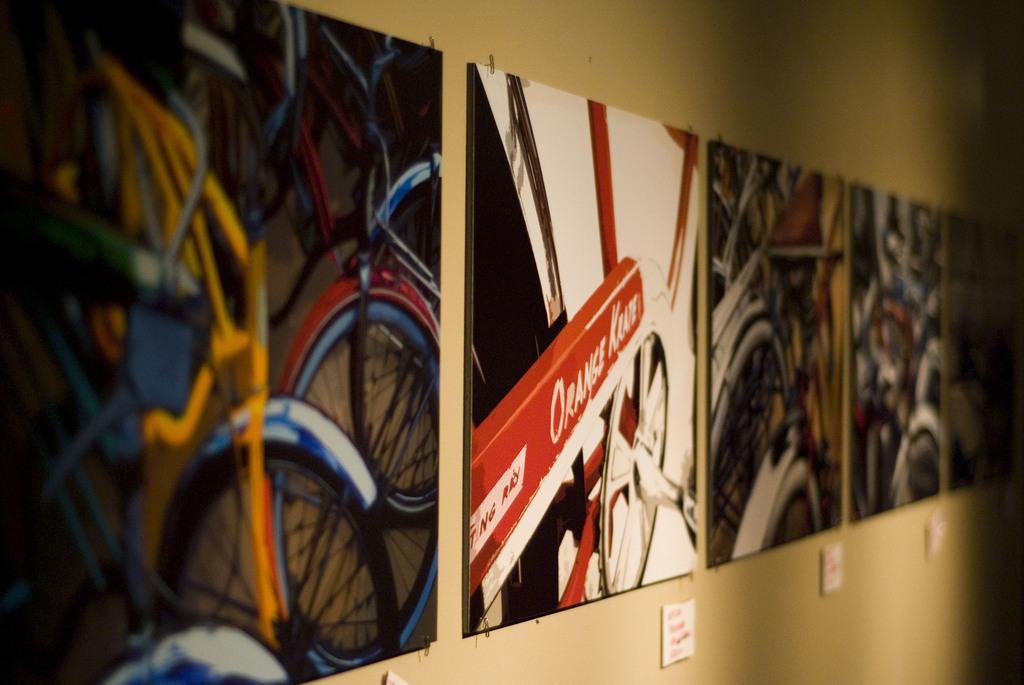In one or two sentences, can you explain what this image depicts? In this image there are posters on the wall with some text and images on it. 